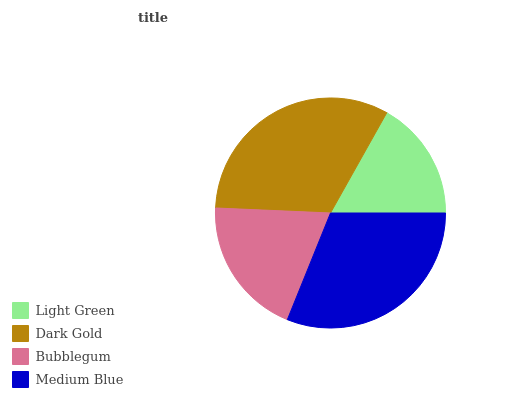Is Light Green the minimum?
Answer yes or no. Yes. Is Dark Gold the maximum?
Answer yes or no. Yes. Is Bubblegum the minimum?
Answer yes or no. No. Is Bubblegum the maximum?
Answer yes or no. No. Is Dark Gold greater than Bubblegum?
Answer yes or no. Yes. Is Bubblegum less than Dark Gold?
Answer yes or no. Yes. Is Bubblegum greater than Dark Gold?
Answer yes or no. No. Is Dark Gold less than Bubblegum?
Answer yes or no. No. Is Medium Blue the high median?
Answer yes or no. Yes. Is Bubblegum the low median?
Answer yes or no. Yes. Is Light Green the high median?
Answer yes or no. No. Is Medium Blue the low median?
Answer yes or no. No. 